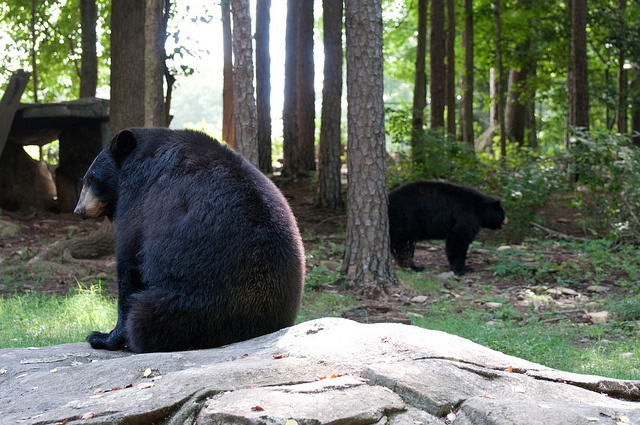Describe the objects in this image and their specific colors. I can see bear in green, black, gray, and darkblue tones and bear in green, black, gray, and darkgreen tones in this image. 